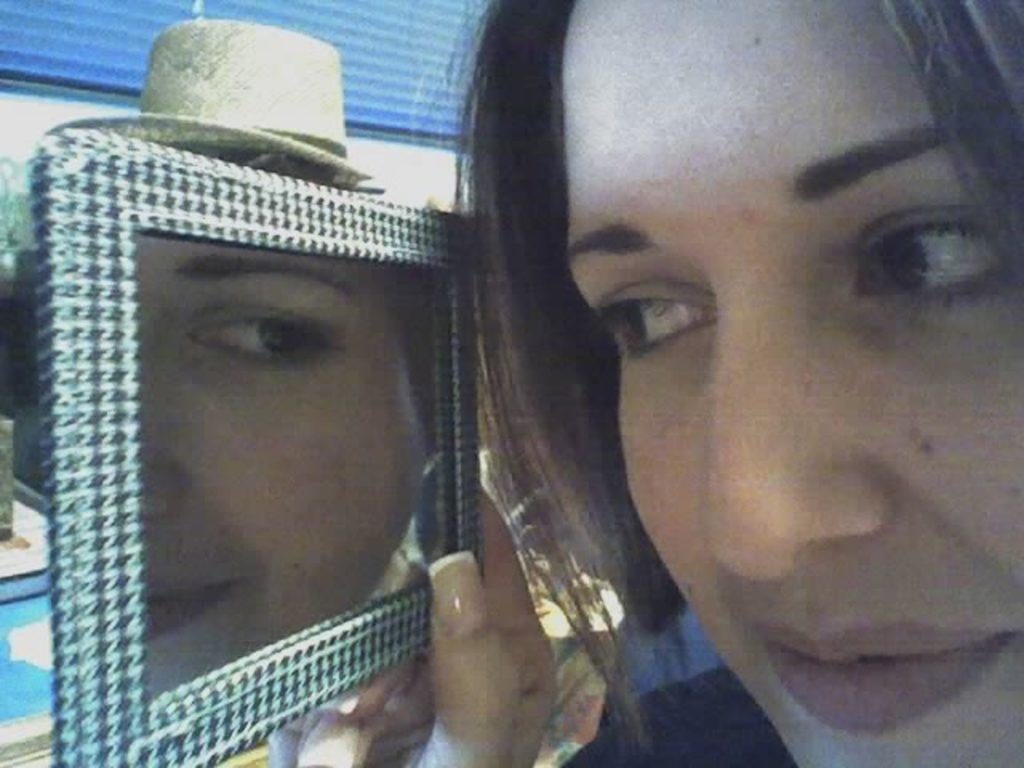What is the person in the image doing? The person is holding a mirror and peeping into it. What object is the person holding? The person is holding a mirror. What can be seen in the background of the image? There is a hat and a window shutter in the background of the image. What is the number of zinc elements present in the image? There is no zinc element present in the image. How can the person in the image join the mirror to the hat? The person is not attempting to join the mirror to the hat in the image. 